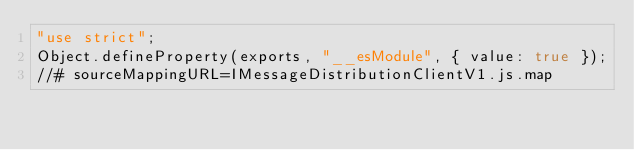<code> <loc_0><loc_0><loc_500><loc_500><_JavaScript_>"use strict";
Object.defineProperty(exports, "__esModule", { value: true });
//# sourceMappingURL=IMessageDistributionClientV1.js.map</code> 